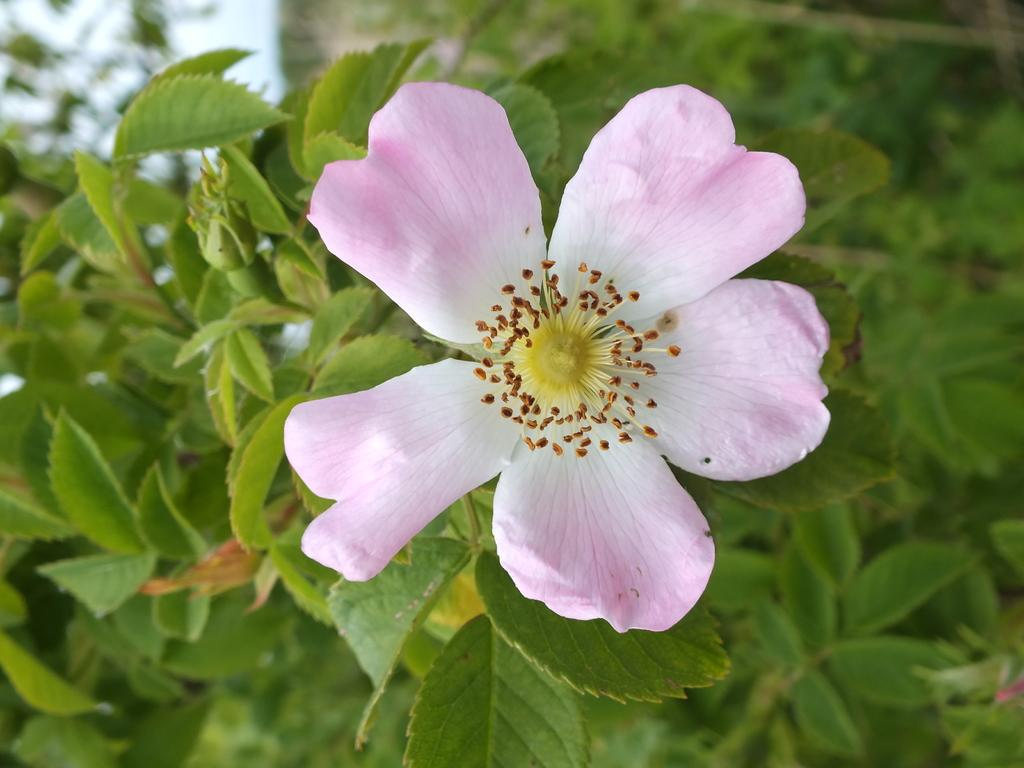What type of plant can be seen in the image? There is a flower in the image. Are there any other plants visible in the image? Yes, there are plants in the image. Can you describe the background of the image? The background of the image is blurred. What type of tiger can be seen in the image? There is no tiger present in the image; it features a flower and other plants. What type of canvas is the image painted on? The image is not a painting, so there is no canvas present. 